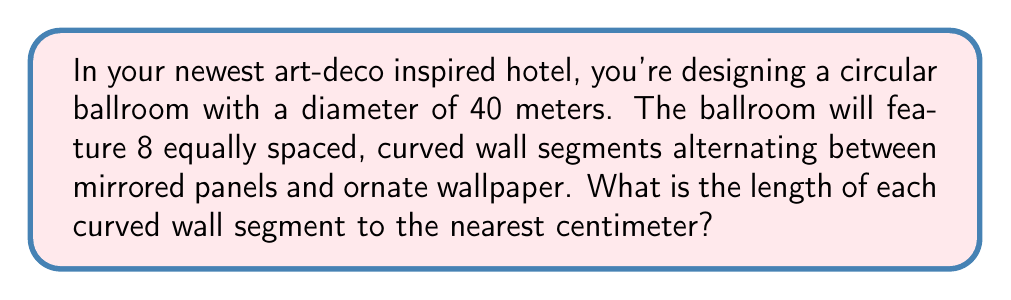Show me your answer to this math problem. To solve this problem, we need to follow these steps:

1) First, we need to understand that the curved wall segments form arcs of a circle. The entire circle is divided into 8 equal parts.

2) The formula for the arc length is:
   
   $$ s = r\theta $$

   Where $s$ is the arc length, $r$ is the radius, and $\theta$ is the central angle in radians.

3) We're given the diameter of 40 meters. The radius is half of this:
   
   $$ r = 40/2 = 20 \text{ meters} $$

4) For the central angle, we know that a full circle is $2\pi$ radians. Since we're dividing the circle into 8 equal parts, each central angle will be:

   $$ \theta = 2\pi/8 = \pi/4 \text{ radians} $$

5) Now we can plug these values into our arc length formula:

   $$ s = r\theta = 20 \cdot (\pi/4) = 5\pi \text{ meters} $$

6) To convert this to centimeters and round to the nearest centimeter:

   $$ s = 5\pi \cdot 100 \approx 1570.80 \text{ cm} $$

   Rounding to the nearest centimeter gives us 1571 cm.

[asy]
import geometry;

size(200);
pair O = (0,0);
real r = 5;
path c = circle(O, r);
draw(c);
for(int i = 0; i < 8; ++i) {
  draw(rotate(45*i)*((r,0)--(0,0)));
}
draw(arc(O, (r,0), 45), linewidth(2));
label("20 m", (r/2,0), E);
label("$\frac{\pi}{4}$", (r/2,r/2), NE);
</asy]
Answer: The length of each curved wall segment is 1571 cm. 